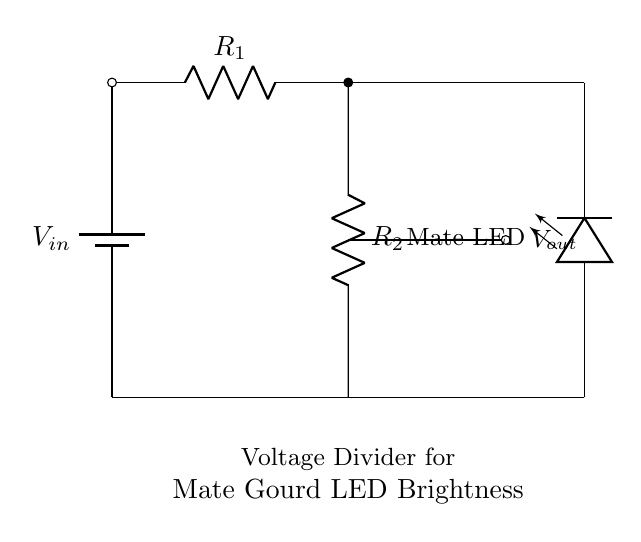What type of circuit is this? This circuit is a voltage divider circuit, which is designed to reduce the voltage across the LED to adjust its brightness. The voltage divider uses two resistors to split the input voltage.
Answer: Voltage divider What is the function of the resistors? The function of the resistors \(R_1\) and \(R_2\) is to divide the input voltage \(V_{in}\) to achieve a specific output voltage \(V_{out}\) for the LED. By adjusting the values of these resistors, the brightness of the LED can be controlled.
Answer: Dividing voltage What does \(V_{out}\) represent in this circuit? \(V_{out}\) represents the output voltage across the second resistor \(R_2\), which determines the voltage supplied to the LED, thus controlling its brightness.
Answer: Output voltage How many resistors are in the circuit? There are two resistors in the circuit: \(R_1\) and \(R_2\), which form the voltage divider.
Answer: Two What happens to the LED brightness if \(R_1\) is increased? If \(R_1\) is increased, the output voltage \(V_{out}\) will decrease, resulting in dimmer LED brightness. This is because a larger resistance means more voltage is dropped across \(R_1\) and less across \(R_2\).
Answer: Dimmer brightness What component is used to indicate the brightness? The LED is the component used to indicate the brightness levels, as it reflects the output voltage \(V_{out}\) supplied by the resistors. Changes in \(V_{out}\) directly affect how bright the LED shines.
Answer: LED 